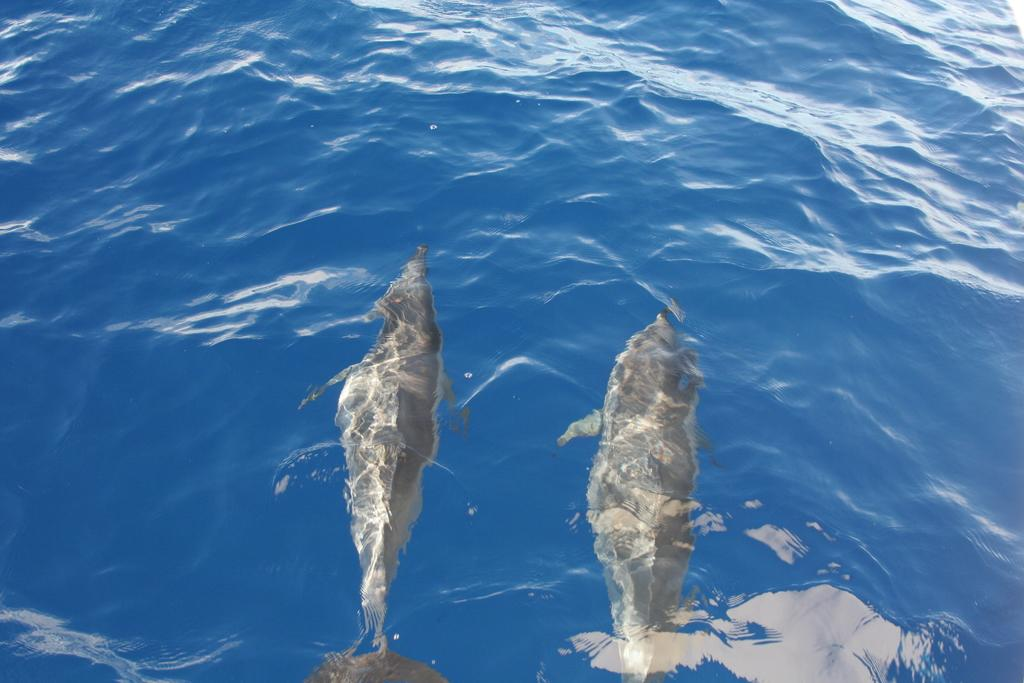What animals are present in the image? There are two fish in the image. Where are the fish located? The fish are in water. What is the primary element in the image? The image contains water. What type of credit card is visible in the image? There is no credit card present in the image; it features two fish in water. How many crates are stacked in the image? There are no crates present in the image. 